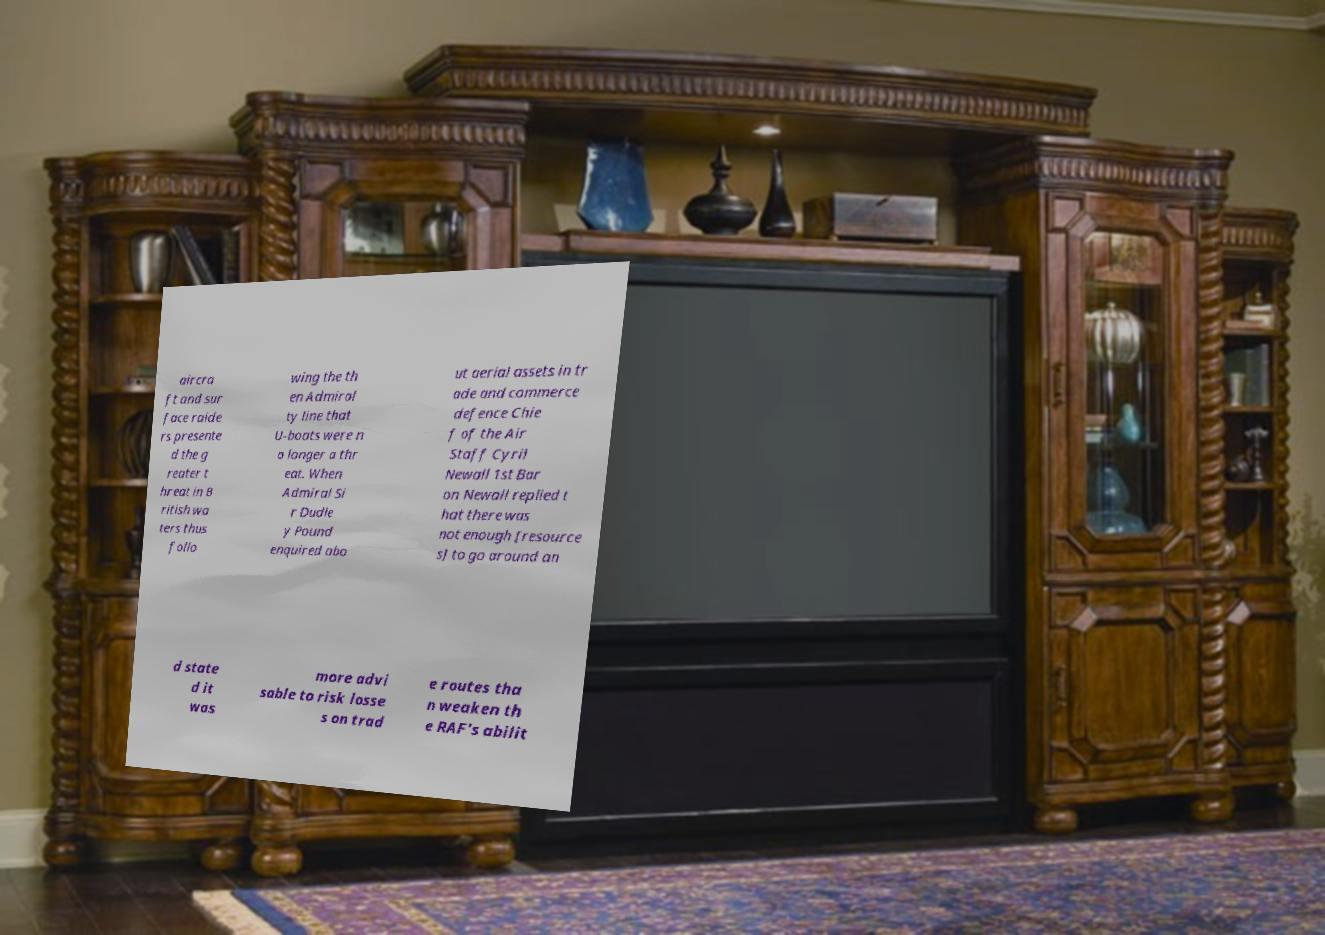There's text embedded in this image that I need extracted. Can you transcribe it verbatim? aircra ft and sur face raide rs presente d the g reater t hreat in B ritish wa ters thus follo wing the th en Admiral ty line that U-boats were n o longer a thr eat. When Admiral Si r Dudle y Pound enquired abo ut aerial assets in tr ade and commerce defence Chie f of the Air Staff Cyril Newall 1st Bar on Newall replied t hat there was not enough [resource s] to go around an d state d it was more advi sable to risk losse s on trad e routes tha n weaken th e RAF's abilit 